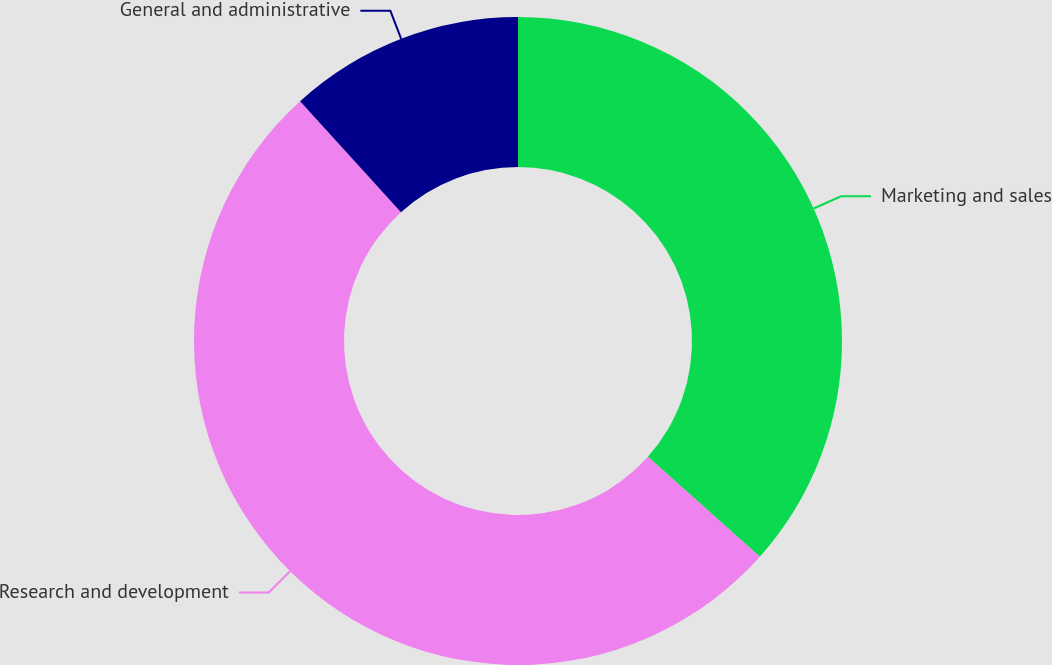Convert chart to OTSL. <chart><loc_0><loc_0><loc_500><loc_500><pie_chart><fcel>Marketing and sales<fcel>Research and development<fcel>General and administrative<nl><fcel>36.59%<fcel>51.67%<fcel>11.74%<nl></chart> 